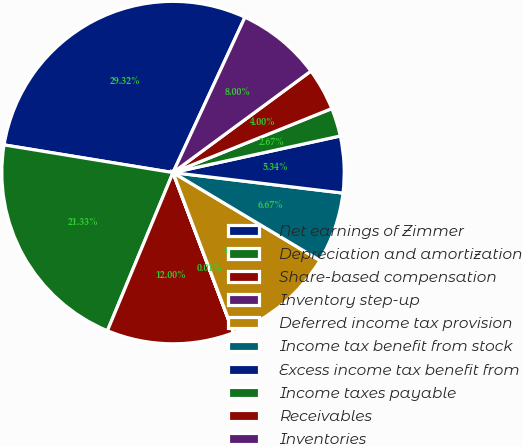Convert chart to OTSL. <chart><loc_0><loc_0><loc_500><loc_500><pie_chart><fcel>Net earnings of Zimmer<fcel>Depreciation and amortization<fcel>Share-based compensation<fcel>Inventory step-up<fcel>Deferred income tax provision<fcel>Income tax benefit from stock<fcel>Excess income tax benefit from<fcel>Income taxes payable<fcel>Receivables<fcel>Inventories<nl><fcel>29.32%<fcel>21.33%<fcel>12.0%<fcel>0.01%<fcel>10.67%<fcel>6.67%<fcel>5.34%<fcel>2.67%<fcel>4.0%<fcel>8.0%<nl></chart> 